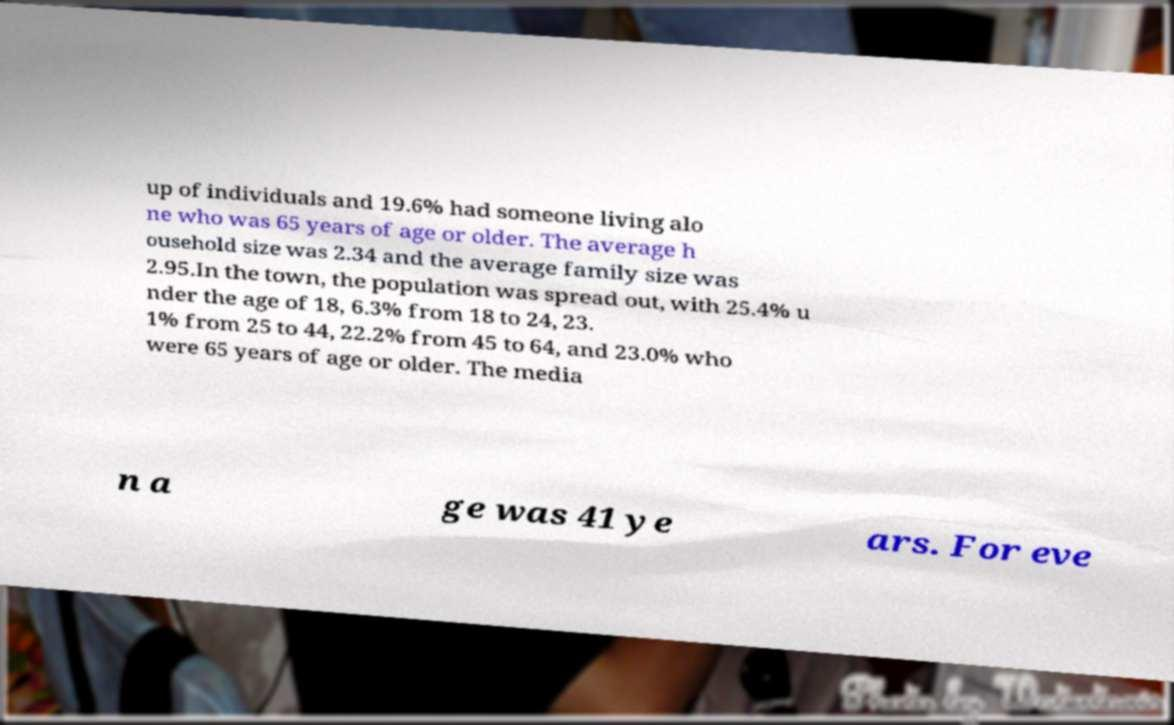I need the written content from this picture converted into text. Can you do that? up of individuals and 19.6% had someone living alo ne who was 65 years of age or older. The average h ousehold size was 2.34 and the average family size was 2.95.In the town, the population was spread out, with 25.4% u nder the age of 18, 6.3% from 18 to 24, 23. 1% from 25 to 44, 22.2% from 45 to 64, and 23.0% who were 65 years of age or older. The media n a ge was 41 ye ars. For eve 